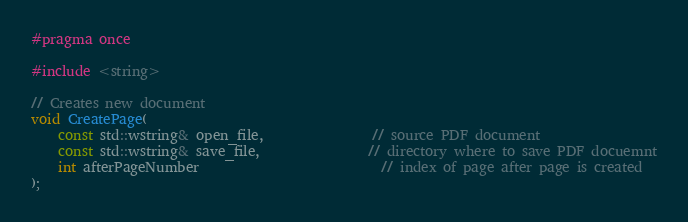<code> <loc_0><loc_0><loc_500><loc_500><_C_>#pragma once

#include <string>

// Creates new document
void CreatePage(
    const std::wstring& open_file,                // source PDF document
    const std::wstring& save_file,                // directory where to save PDF docuemnt
    int afterPageNumber                           // index of page after page is created
);
</code> 